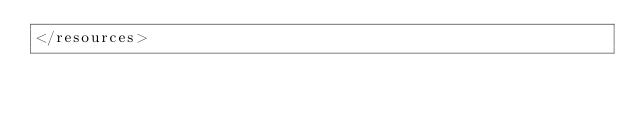<code> <loc_0><loc_0><loc_500><loc_500><_XML_></resources>
</code> 